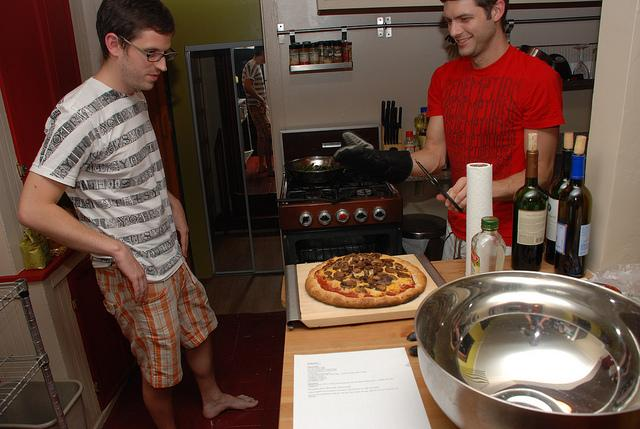How many bottles of wine are to the right in front to the man who is cutting the pizza? Please explain your reasoning. three. There are 3. 